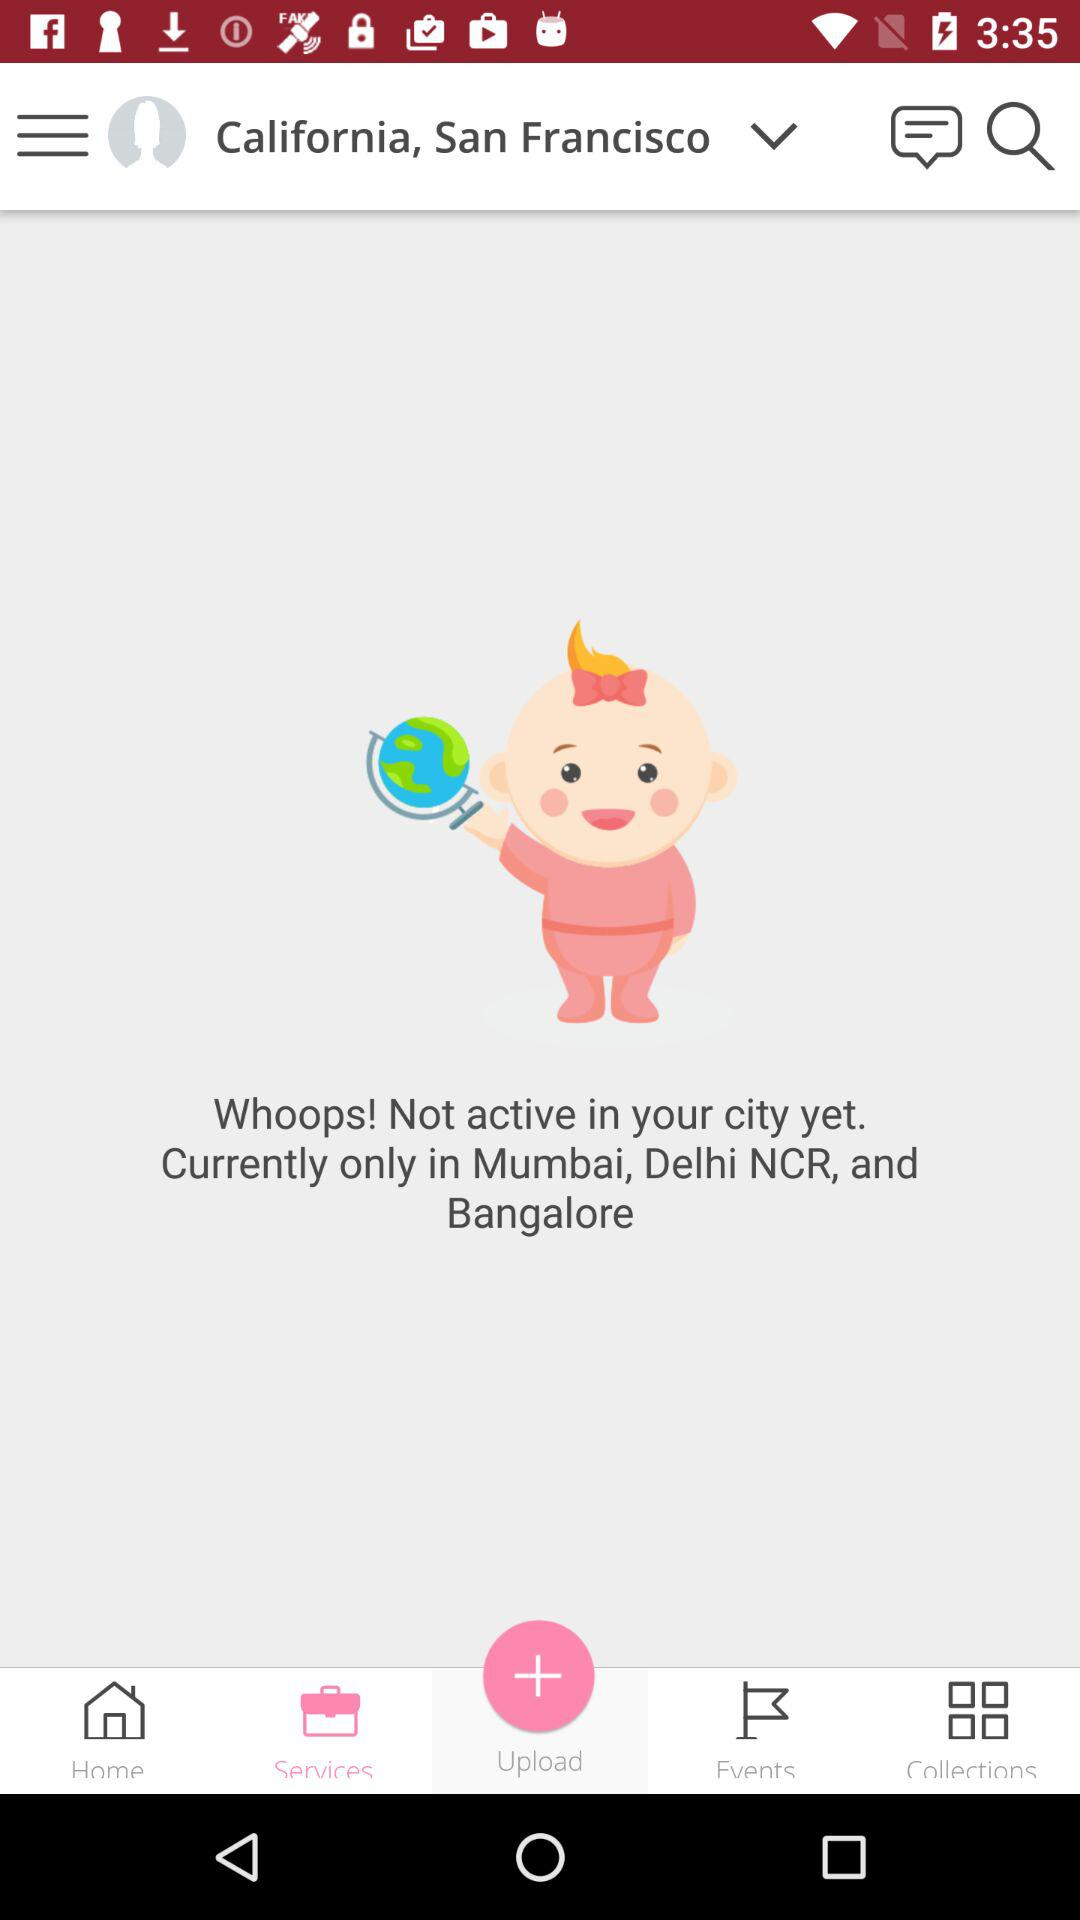Which cities is "Whoops!" currently active in? "Whoops!" is currently active in Mumbai, Delhi NCR, and Bangalore. 